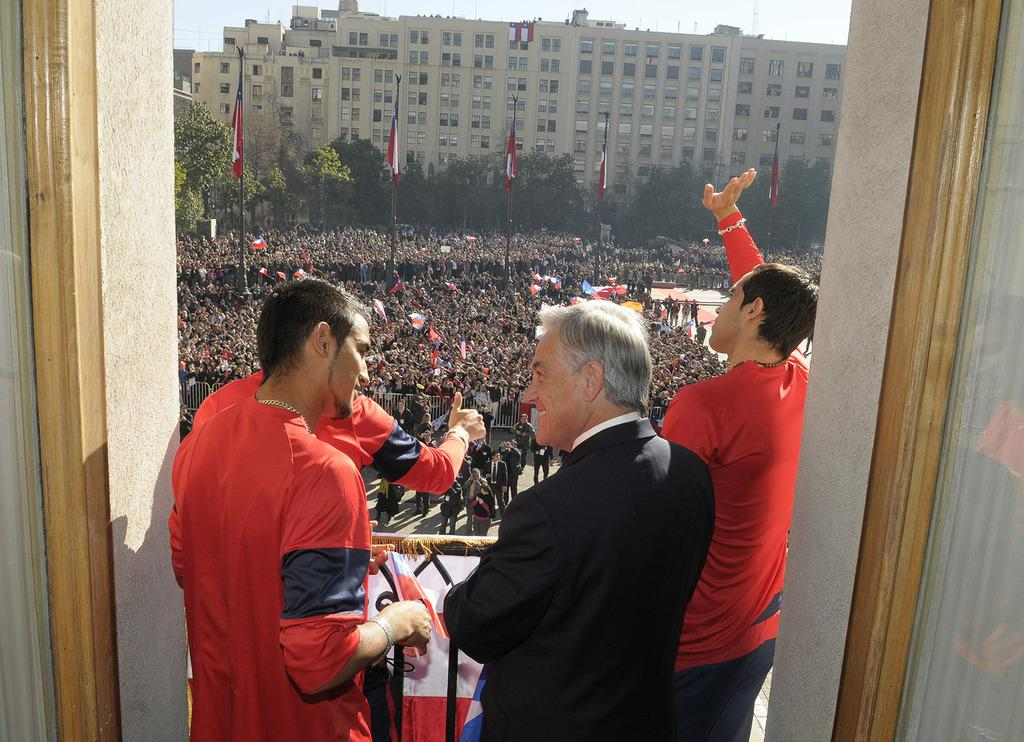How many people are standing in the image? There are four persons standing in the image. What can be seen in the background of the image? There is a group of people, trees, flags with poles, buildings, and the sky visible in the background. What type of mitten is the son wearing in the image? There is no mitten or son present in the image. What nation is represented by the flags in the image? The flags in the image do not have any visible symbols or patterns that would indicate a specific nation. 